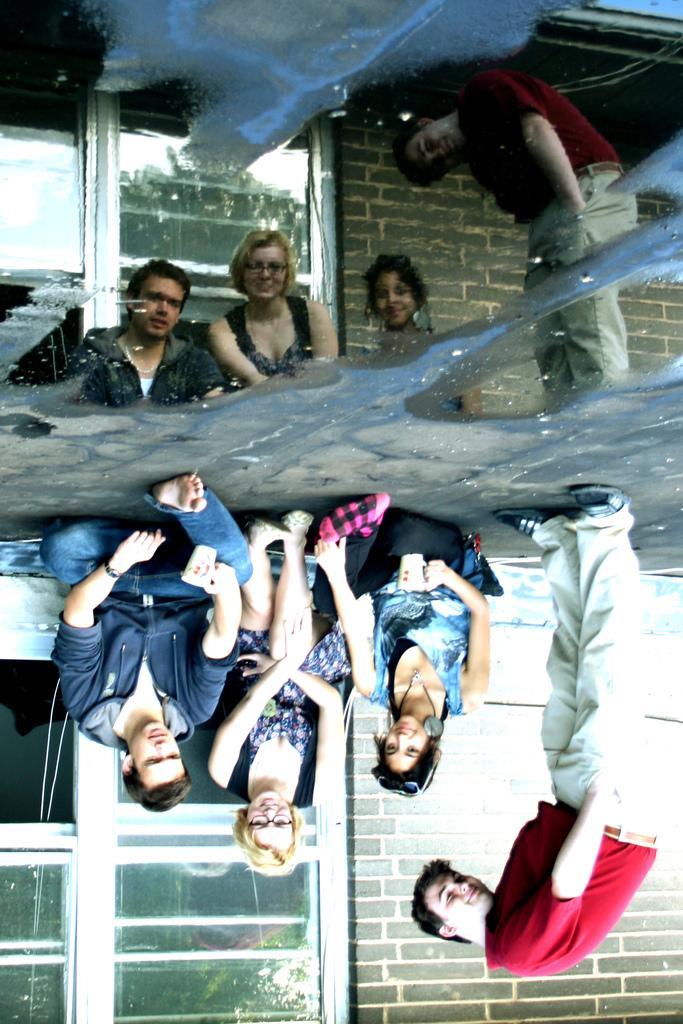Please provide a concise description of this image. In this image we can see the reflection of the image. In this some people are sitting on the ground. One person is standing. In the back there is a building with brick wall and window. And it is on the downside of the image. And we can see the reflection on the topside of the image. 